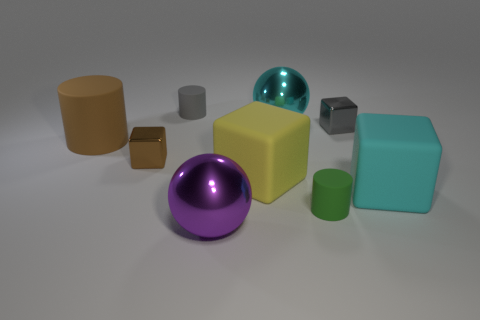There is a matte cylinder behind the small gray object to the right of the gray matte cylinder; what size is it?
Your response must be concise. Small. There is a shiny cube that is to the left of the large cyan ball; is it the same color as the large shiny ball behind the purple metallic thing?
Offer a very short reply. No. How many big spheres are behind the purple object to the left of the metal object that is behind the gray block?
Your response must be concise. 1. What number of small metallic blocks are to the left of the small gray metallic cube and behind the tiny brown shiny block?
Your answer should be compact. 0. Is the number of big cyan shiny spheres that are to the left of the large purple sphere greater than the number of tiny things?
Your answer should be compact. No. What number of metal things are the same size as the cyan ball?
Offer a very short reply. 1. What is the size of the cube that is the same color as the large cylinder?
Your answer should be very brief. Small. How many tiny objects are yellow metal blocks or cyan matte objects?
Offer a terse response. 0. How many tiny yellow things are there?
Ensure brevity in your answer.  0. Is the number of rubber cylinders behind the cyan shiny ball the same as the number of large yellow objects that are left of the big brown matte cylinder?
Make the answer very short. No. 